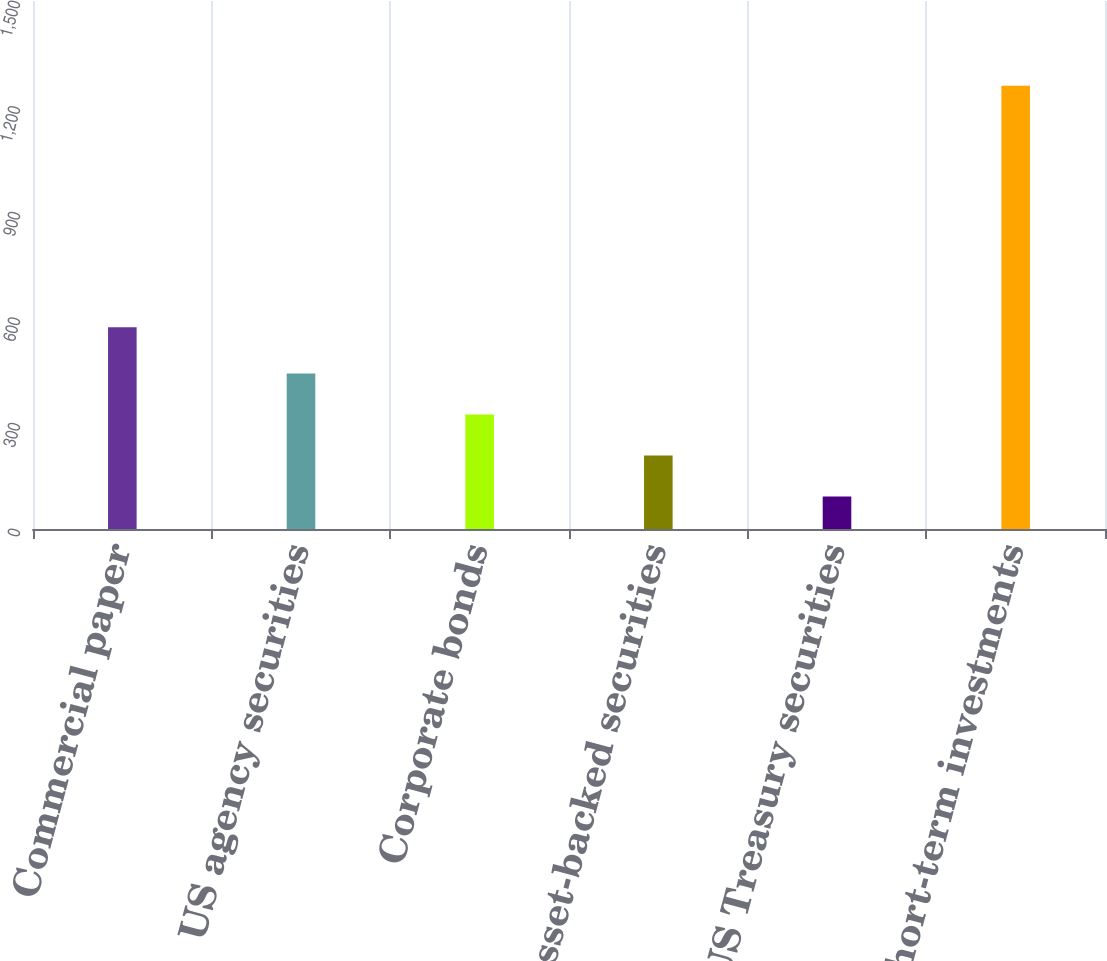<chart> <loc_0><loc_0><loc_500><loc_500><bar_chart><fcel>Commercial paper<fcel>US agency securities<fcel>Corporate bonds<fcel>Asset-backed securities<fcel>US Treasury securities<fcel>Total short-term investments<nl><fcel>573<fcel>442.1<fcel>325.4<fcel>208.7<fcel>92<fcel>1259<nl></chart> 